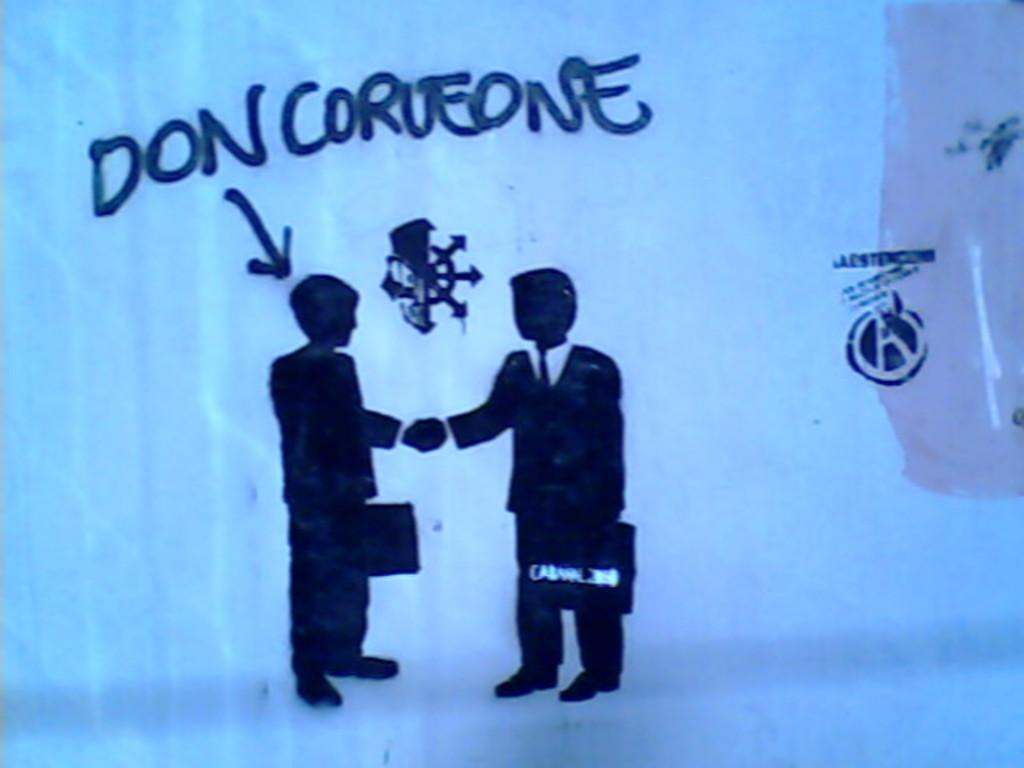Provide a one-sentence caption for the provided image. A silhouette of two men shaking hands, one of which is named Don Corueone. 